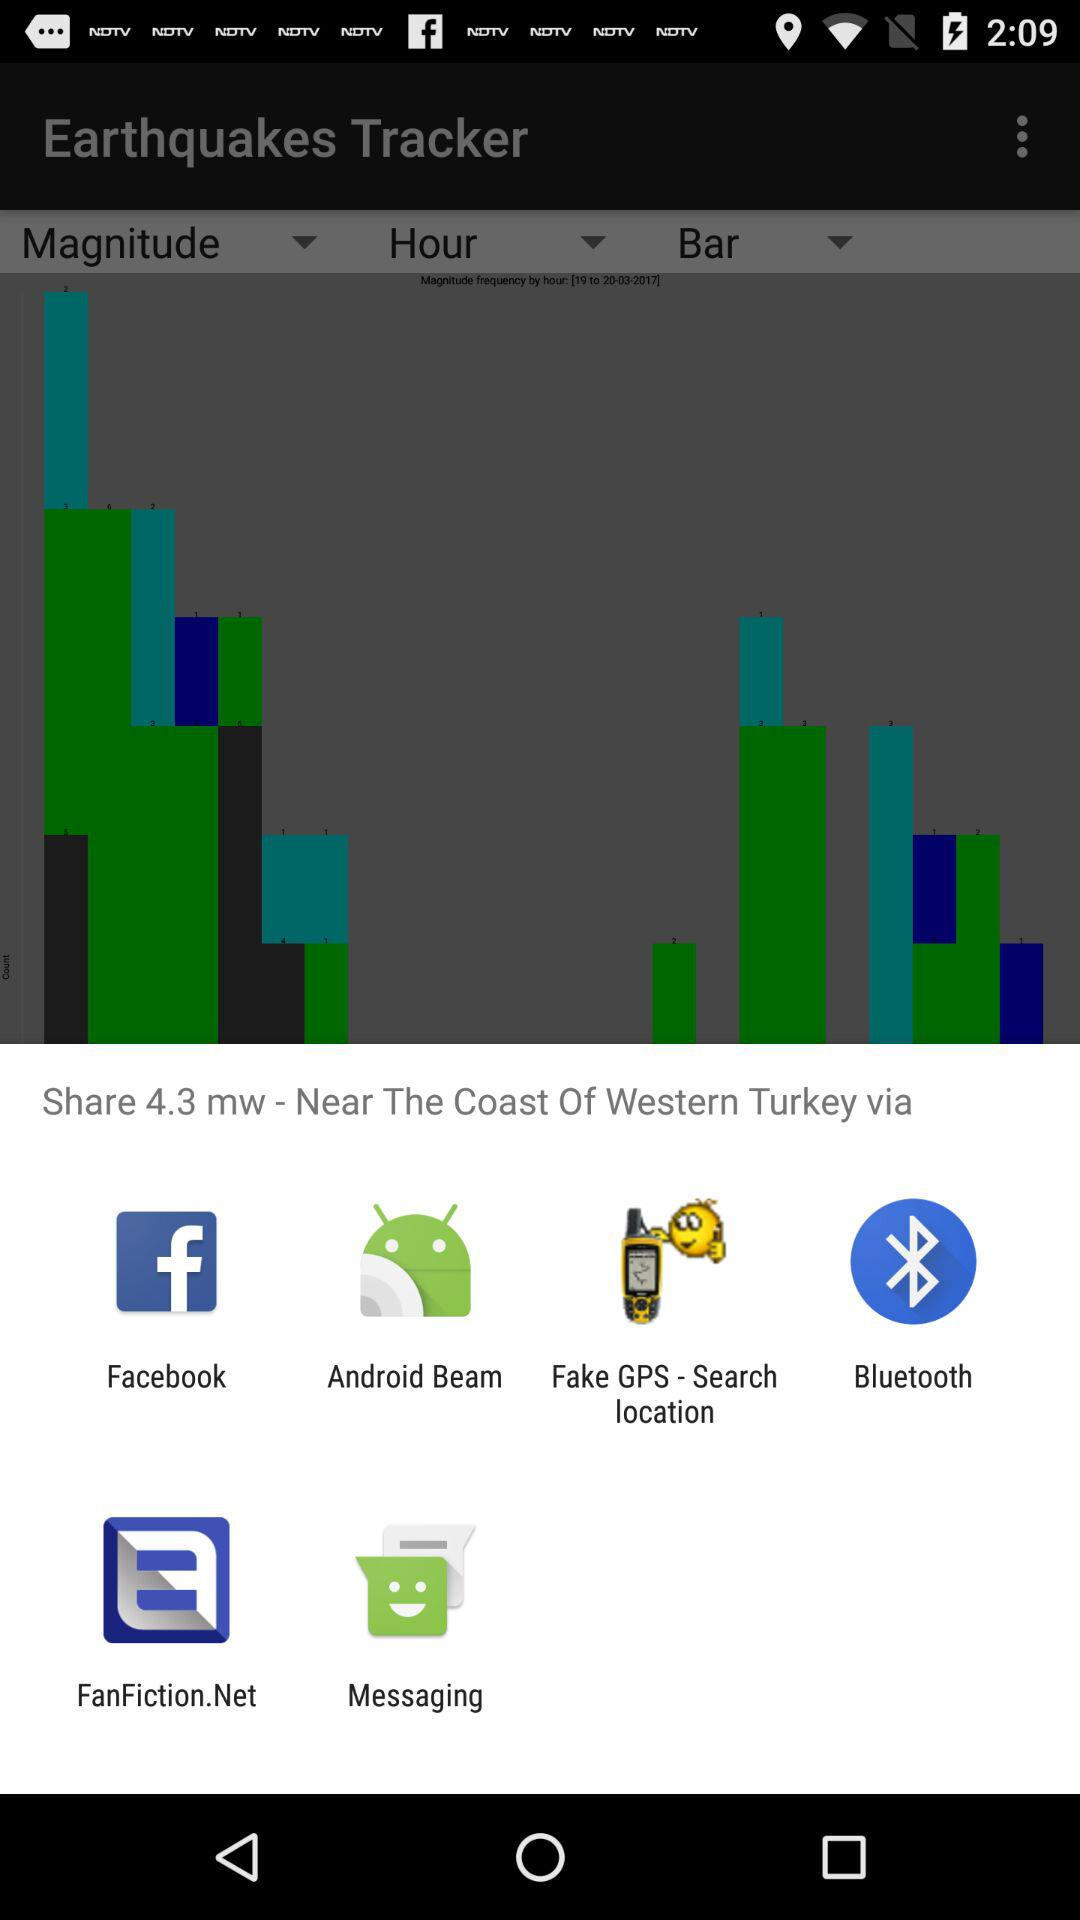What is the application's name? The application's names are "Earthquakes Tracker", "Facebook", "Android Beam", "Fake GPS - Search location", "Bluetooth", "FanFiction.Net" and "Messaging". 